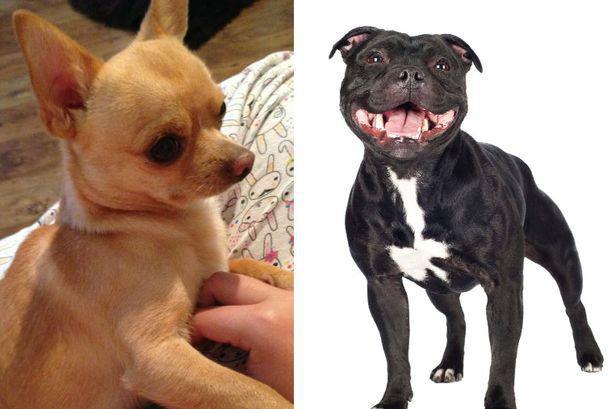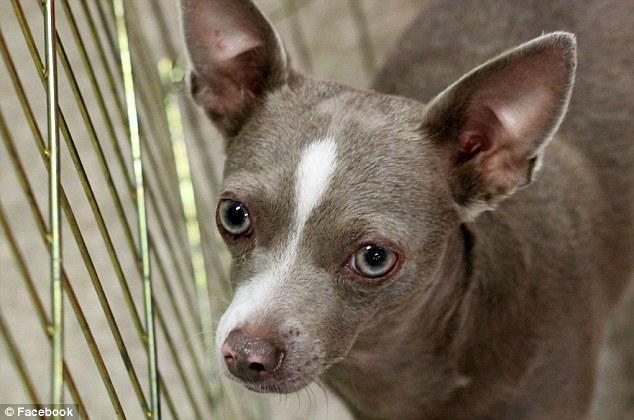The first image is the image on the left, the second image is the image on the right. Analyze the images presented: Is the assertion "The left image features a fang-bearing chihuahua, and the right image features a chihuhua in costume-like get-up." valid? Answer yes or no. No. The first image is the image on the left, the second image is the image on the right. Examine the images to the left and right. Is the description "A chihuahua is wearing an article of clothing int he right image." accurate? Answer yes or no. No. 